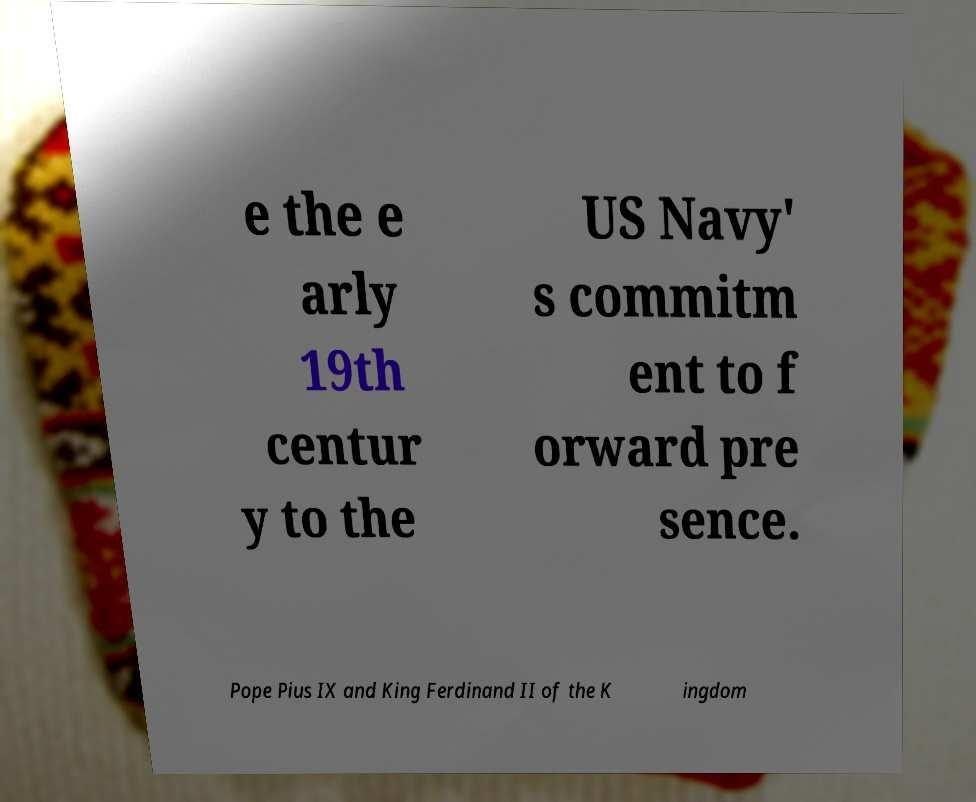Can you accurately transcribe the text from the provided image for me? e the e arly 19th centur y to the US Navy' s commitm ent to f orward pre sence. Pope Pius IX and King Ferdinand II of the K ingdom 